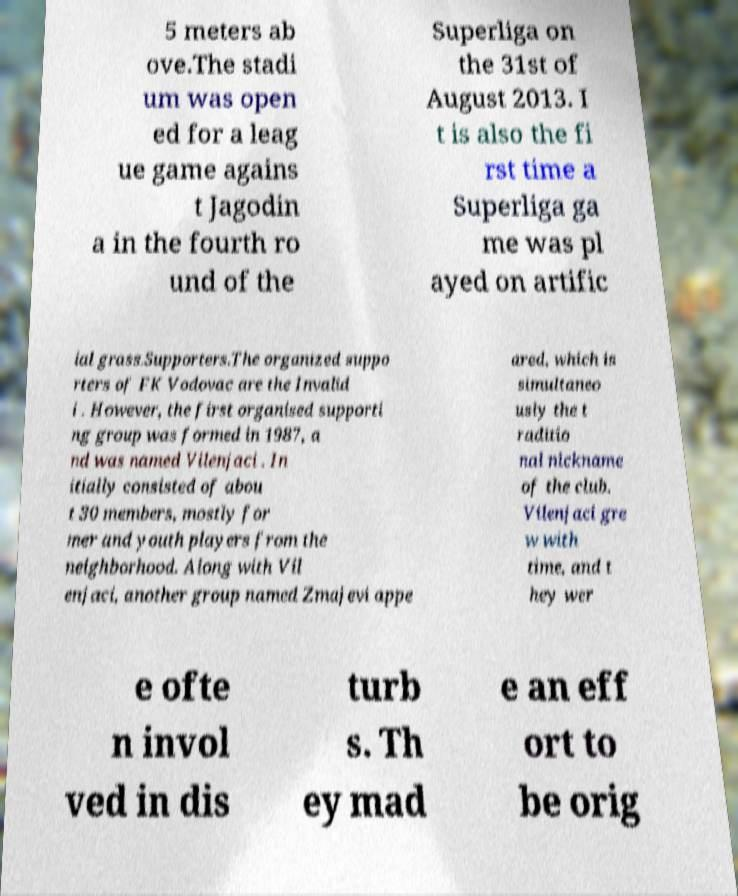Could you extract and type out the text from this image? 5 meters ab ove.The stadi um was open ed for a leag ue game agains t Jagodin a in the fourth ro und of the Superliga on the 31st of August 2013. I t is also the fi rst time a Superliga ga me was pl ayed on artific ial grass.Supporters.The organized suppo rters of FK Vodovac are the Invalid i . However, the first organised supporti ng group was formed in 1987, a nd was named Vilenjaci . In itially consisted of abou t 30 members, mostly for mer and youth players from the neighborhood. Along with Vil enjaci, another group named Zmajevi appe ared, which is simultaneo usly the t raditio nal nickname of the club. Vilenjaci gre w with time, and t hey wer e ofte n invol ved in dis turb s. Th ey mad e an eff ort to be orig 